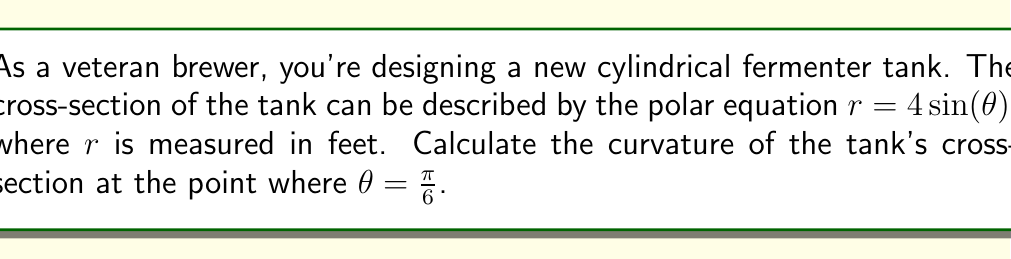Help me with this question. To solve this problem, we'll follow these steps:

1) The general formula for curvature $\kappa$ in polar coordinates is:

   $$\kappa = \frac{|r^2 + 2(r')^2 - rr''|}{(r^2 + (r')^2)^{3/2}}$$

   where $r'$ and $r''$ are the first and second derivatives of $r$ with respect to $\theta$.

2) Given equation: $r = 4\sin(\theta)$

3) Calculate $r'$:
   $$r' = 4\cos(\theta)$$

4) Calculate $r''$:
   $$r'' = -4\sin(\theta)$$

5) Now, let's substitute these into our curvature formula:

   $$\kappa = \frac{|(4\sin(\theta))^2 + 2(4\cos(\theta))^2 - (4\sin(\theta))(-4\sin(\theta))|}{((4\sin(\theta))^2 + (4\cos(\theta))^2)^{3/2}}$$

6) Simplify:
   $$\kappa = \frac{|16\sin^2(\theta) + 32\cos^2(\theta) + 16\sin^2(\theta)|}{(16\sin^2(\theta) + 16\cos^2(\theta))^{3/2}}$$

   $$\kappa = \frac{|16\sin^2(\theta) + 32\cos^2(\theta) + 16\sin^2(\theta)|}{(16(\sin^2(\theta) + \cos^2(\theta)))^{3/2}}$$

   $$\kappa = \frac{|32\sin^2(\theta) + 32\cos^2(\theta)|}{(16)^{3/2}}$$

   $$\kappa = \frac{32|\sin^2(\theta) + \cos^2(\theta)|}{64}$$

7) We know that $\sin^2(\theta) + \cos^2(\theta) = 1$ for all $\theta$, so:

   $$\kappa = \frac{32}{64} = \frac{1}{2}$$

8) This result is constant for all $\theta$, including $\theta = \frac{\pi}{6}$.

Therefore, the curvature of the tank's cross-section is $\frac{1}{2}$ at all points, including $\theta = \frac{\pi}{6}$.
Answer: $\frac{1}{2}$ ft$^{-1}$ 